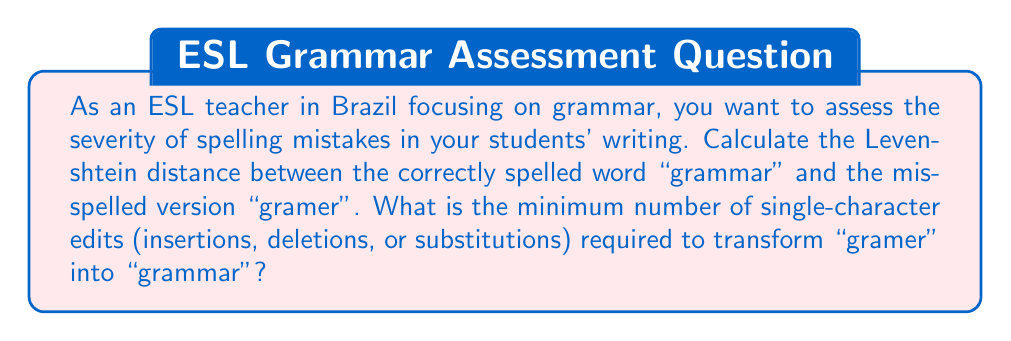Help me with this question. To calculate the Levenshtein distance between "gramer" and "grammar", we need to determine the minimum number of single-character edits required to transform one word into the other. Let's use a dynamic programming approach:

1. Create a matrix $D$ with dimensions $(m+1) \times (n+1)$, where $m$ and $n$ are the lengths of the two words:

   $$
   \begin{array}{c|cccccccc}
     & & g & r & a & m & e & r \\
   \hline
     & 0 & 1 & 2 & 3 & 4 & 5 & 6 \\
   g & 1 & & & & & & \\
   r & 2 & & & & & & \\
   a & 3 & & & & & & \\
   m & 4 & & & & & & \\
   m & 5 & & & & & & \\
   a & 6 & & & & & & \\
   r & 7 & & & & & & \\
   \end{array}
   $$

2. Fill the matrix using the following rule:
   $$D[i,j] = \min \begin{cases}
   D[i-1,j] + 1 & \text{(deletion)} \\
   D[i,j-1] + 1 & \text{(insertion)} \\
   D[i-1,j-1] + \mathbb{1}(s_i \neq t_j) & \text{(substitution)}
   \end{cases}$$

   Where $\mathbb{1}(s_i \neq t_j)$ is 1 if the characters are different, and 0 if they are the same.

3. After filling the matrix, we get:

   $$
   \begin{array}{c|cccccccc}
     & & g & r & a & m & e & r \\
   \hline
     & 0 & 1 & 2 & 3 & 4 & 5 & 6 \\
   g & 1 & 0 & 1 & 2 & 3 & 4 & 5 \\
   r & 2 & 1 & 0 & 1 & 2 & 3 & 4 \\
   a & 3 & 2 & 1 & 0 & 1 & 2 & 3 \\
   m & 4 & 3 & 2 & 1 & 0 & 1 & 2 \\
   m & 5 & 4 & 3 & 2 & 1 & 1 & 2 \\
   a & 6 & 5 & 4 & 3 & 2 & 2 & 2 \\
   r & 7 & 6 & 5 & 4 & 3 & 3 & 2 \\
   \end{array}
   $$

4. The Levenshtein distance is the value in the bottom-right cell of the matrix, which is 2.

This means that we need 2 single-character edits to transform "gramer" into "grammar":
1. Insert 'm' after the first 'm'
2. Insert 'a' before the final 'r'
Answer: The Levenshtein distance between "gramer" and "grammar" is $2$. 